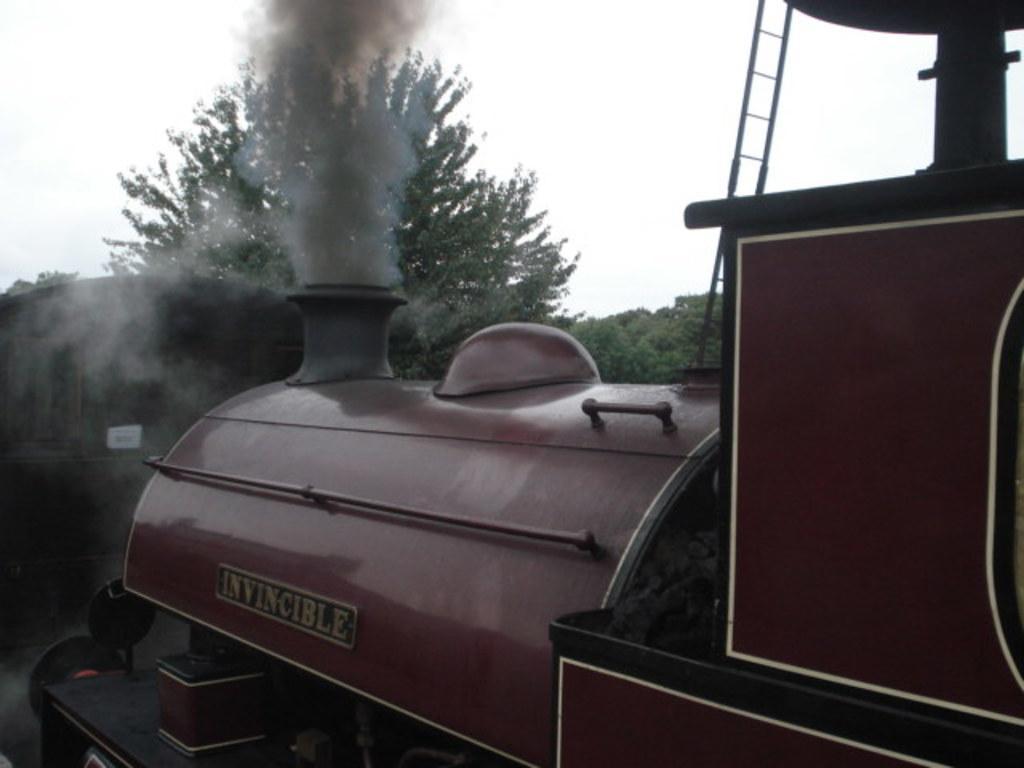Could you give a brief overview of what you see in this image? In the image we can see steam engine, ladder, trees and the sky. 